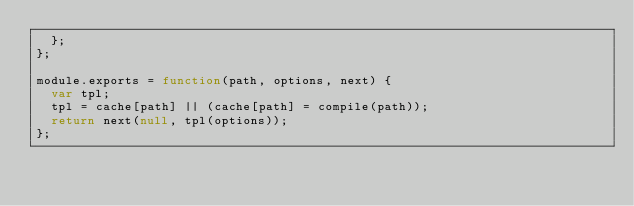Convert code to text. <code><loc_0><loc_0><loc_500><loc_500><_JavaScript_>  };
};

module.exports = function(path, options, next) {
  var tpl;
  tpl = cache[path] || (cache[path] = compile(path));
  return next(null, tpl(options));
};
</code> 